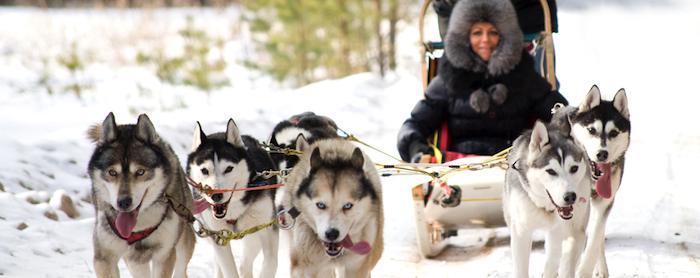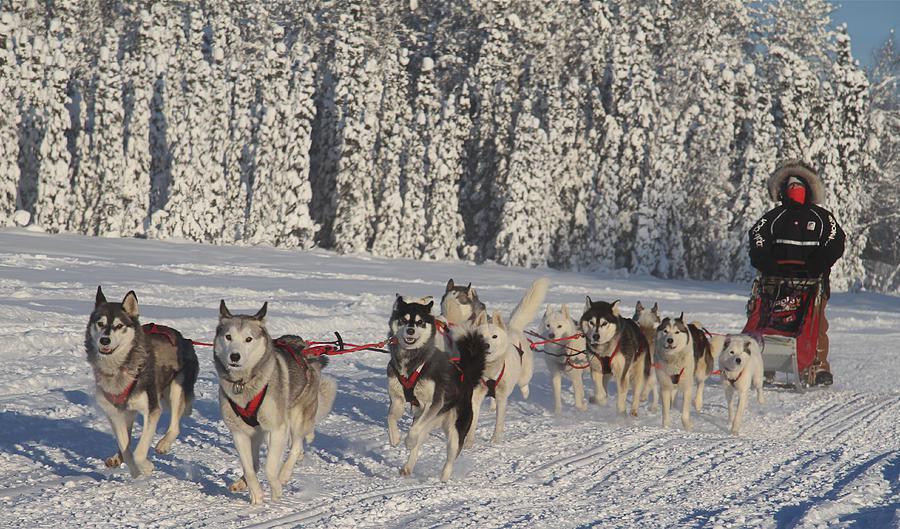The first image is the image on the left, the second image is the image on the right. For the images shown, is this caption "There is snow on the trees in one of the images." true? Answer yes or no. Yes. 